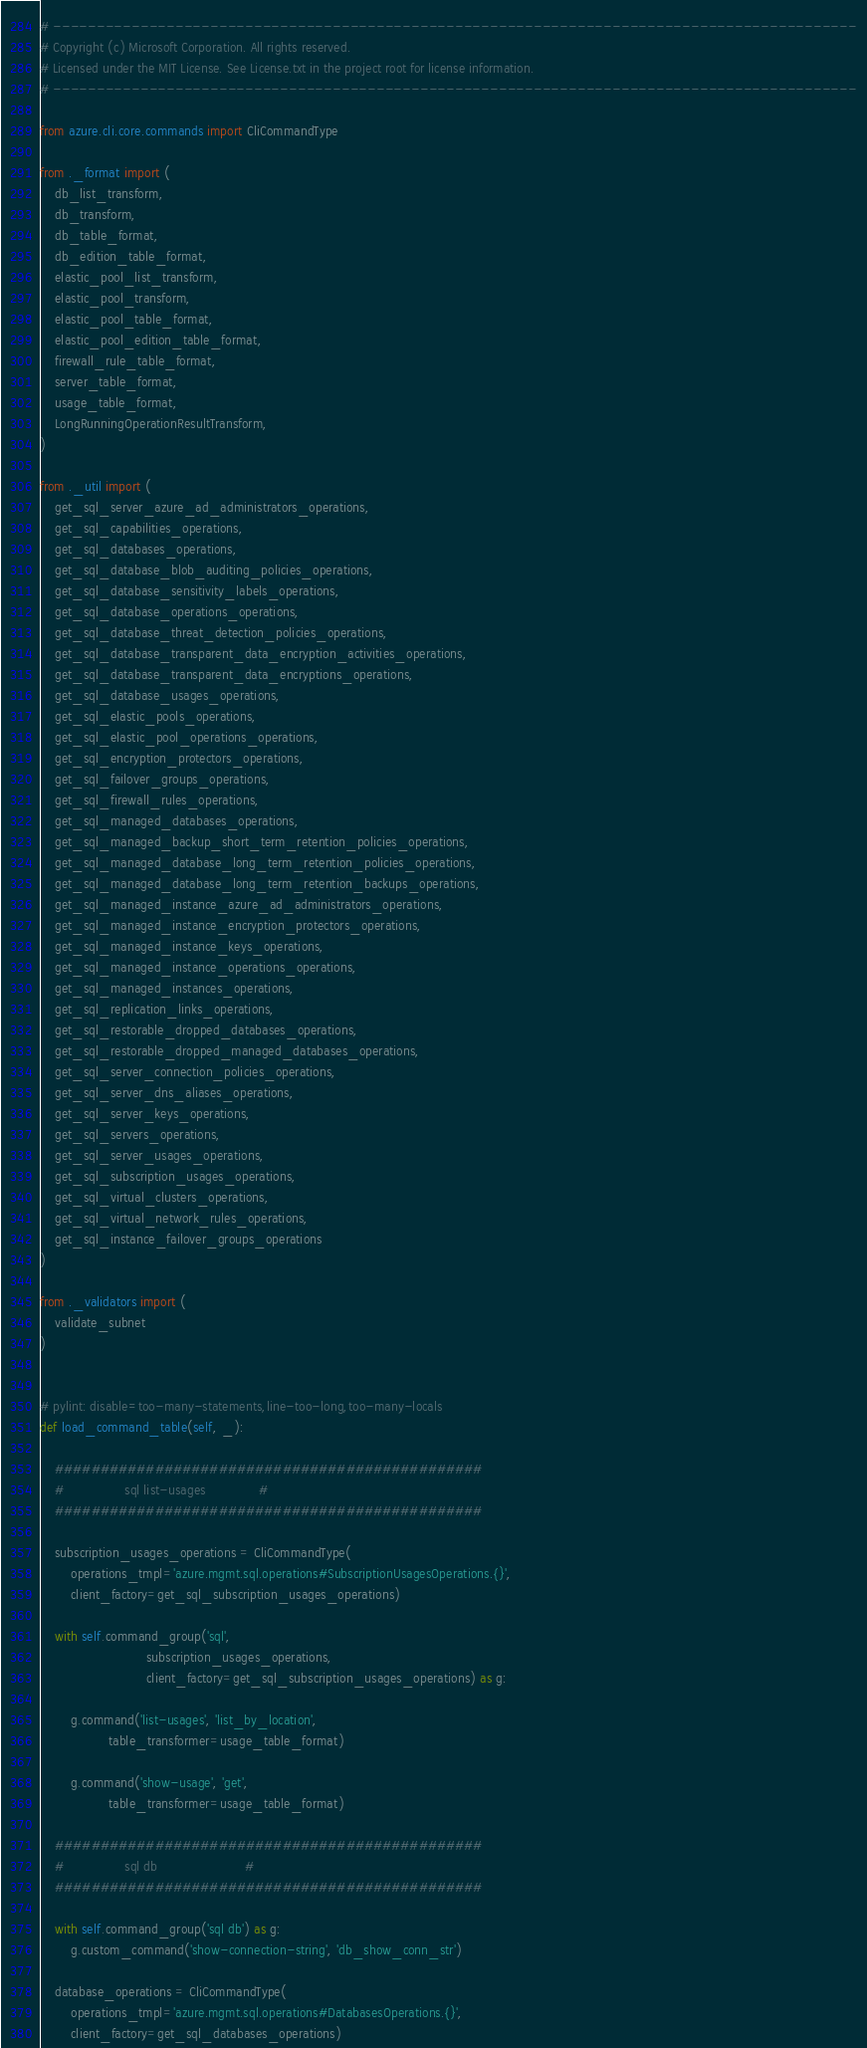<code> <loc_0><loc_0><loc_500><loc_500><_Python_># --------------------------------------------------------------------------------------------
# Copyright (c) Microsoft Corporation. All rights reserved.
# Licensed under the MIT License. See License.txt in the project root for license information.
# --------------------------------------------------------------------------------------------

from azure.cli.core.commands import CliCommandType

from ._format import (
    db_list_transform,
    db_transform,
    db_table_format,
    db_edition_table_format,
    elastic_pool_list_transform,
    elastic_pool_transform,
    elastic_pool_table_format,
    elastic_pool_edition_table_format,
    firewall_rule_table_format,
    server_table_format,
    usage_table_format,
    LongRunningOperationResultTransform,
)

from ._util import (
    get_sql_server_azure_ad_administrators_operations,
    get_sql_capabilities_operations,
    get_sql_databases_operations,
    get_sql_database_blob_auditing_policies_operations,
    get_sql_database_sensitivity_labels_operations,
    get_sql_database_operations_operations,
    get_sql_database_threat_detection_policies_operations,
    get_sql_database_transparent_data_encryption_activities_operations,
    get_sql_database_transparent_data_encryptions_operations,
    get_sql_database_usages_operations,
    get_sql_elastic_pools_operations,
    get_sql_elastic_pool_operations_operations,
    get_sql_encryption_protectors_operations,
    get_sql_failover_groups_operations,
    get_sql_firewall_rules_operations,
    get_sql_managed_databases_operations,
    get_sql_managed_backup_short_term_retention_policies_operations,
    get_sql_managed_database_long_term_retention_policies_operations,
    get_sql_managed_database_long_term_retention_backups_operations,
    get_sql_managed_instance_azure_ad_administrators_operations,
    get_sql_managed_instance_encryption_protectors_operations,
    get_sql_managed_instance_keys_operations,
    get_sql_managed_instance_operations_operations,
    get_sql_managed_instances_operations,
    get_sql_replication_links_operations,
    get_sql_restorable_dropped_databases_operations,
    get_sql_restorable_dropped_managed_databases_operations,
    get_sql_server_connection_policies_operations,
    get_sql_server_dns_aliases_operations,
    get_sql_server_keys_operations,
    get_sql_servers_operations,
    get_sql_server_usages_operations,
    get_sql_subscription_usages_operations,
    get_sql_virtual_clusters_operations,
    get_sql_virtual_network_rules_operations,
    get_sql_instance_failover_groups_operations
)

from ._validators import (
    validate_subnet
)


# pylint: disable=too-many-statements,line-too-long,too-many-locals
def load_command_table(self, _):

    ###############################################
    #                sql list-usages              #
    ###############################################

    subscription_usages_operations = CliCommandType(
        operations_tmpl='azure.mgmt.sql.operations#SubscriptionUsagesOperations.{}',
        client_factory=get_sql_subscription_usages_operations)

    with self.command_group('sql',
                            subscription_usages_operations,
                            client_factory=get_sql_subscription_usages_operations) as g:

        g.command('list-usages', 'list_by_location',
                  table_transformer=usage_table_format)

        g.command('show-usage', 'get',
                  table_transformer=usage_table_format)

    ###############################################
    #                sql db                       #
    ###############################################

    with self.command_group('sql db') as g:
        g.custom_command('show-connection-string', 'db_show_conn_str')

    database_operations = CliCommandType(
        operations_tmpl='azure.mgmt.sql.operations#DatabasesOperations.{}',
        client_factory=get_sql_databases_operations)
</code> 